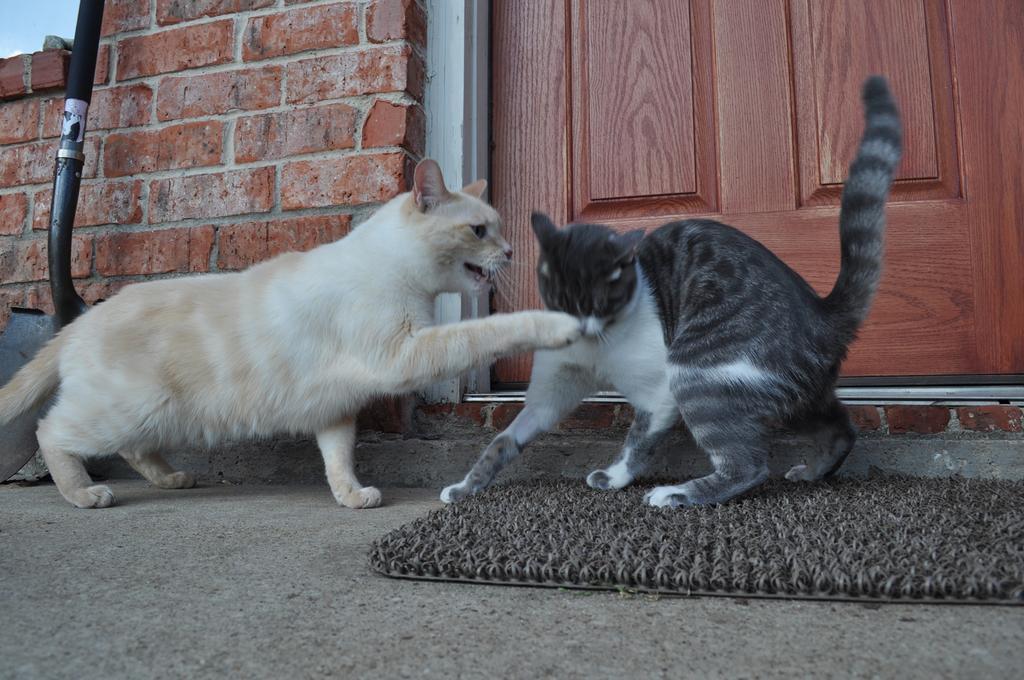Please provide a concise description of this image. In this image I can see two cats. In the background, I can see the wall and a door. 